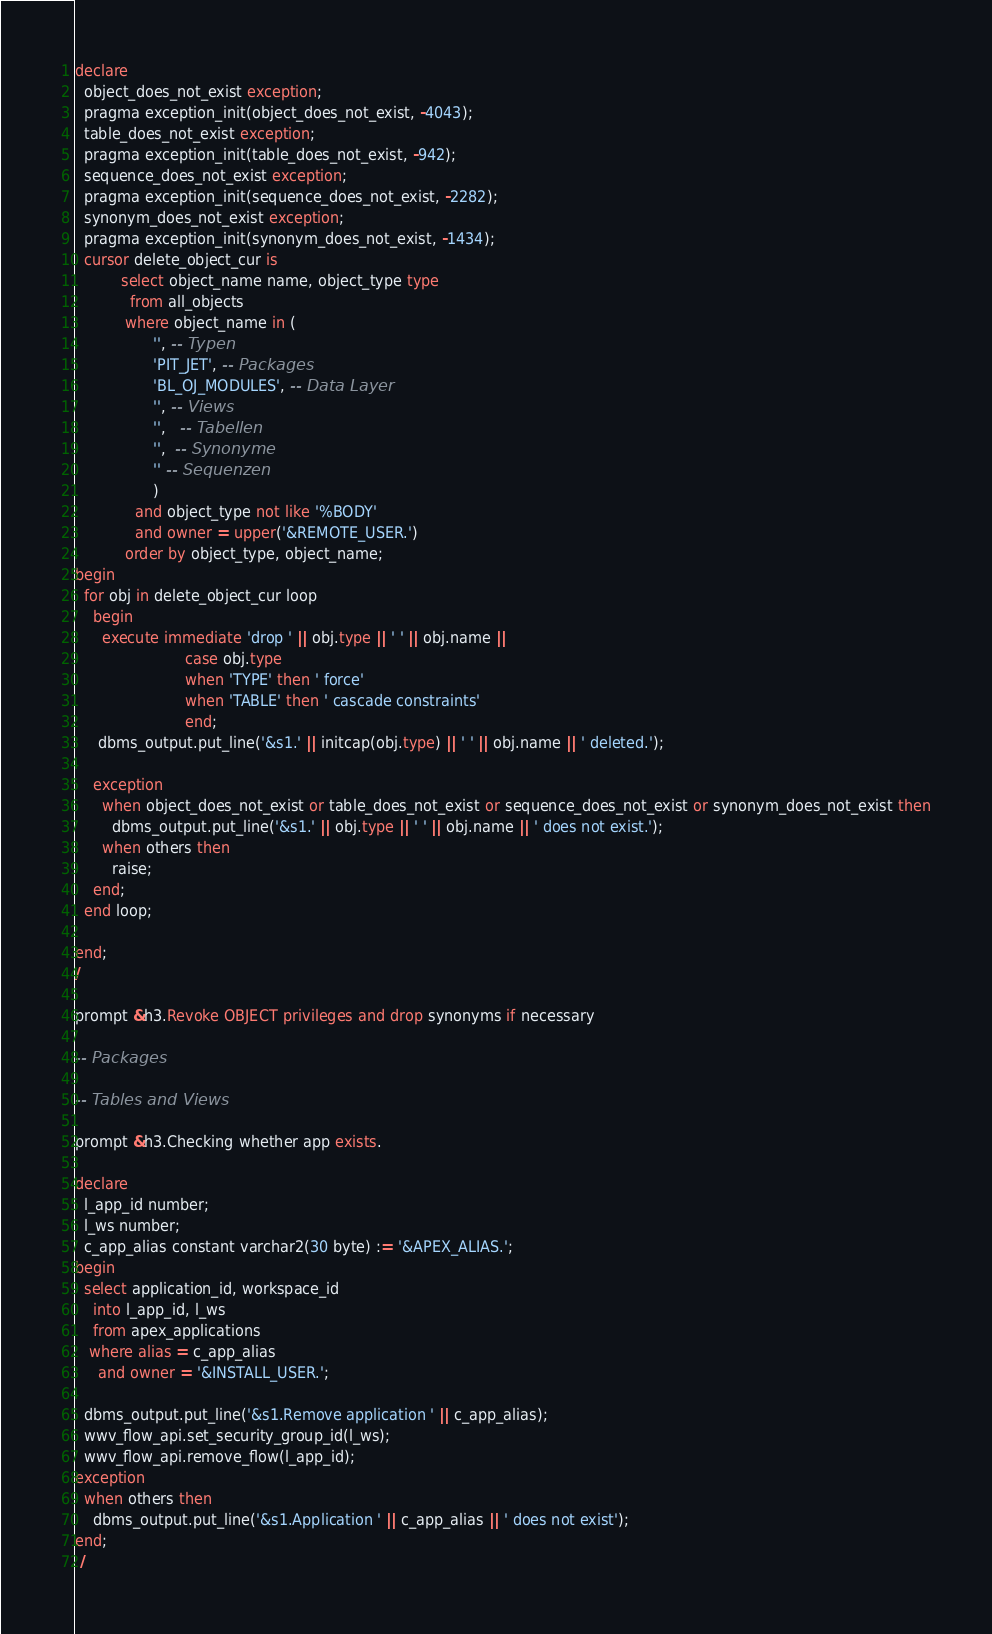<code> <loc_0><loc_0><loc_500><loc_500><_SQL_>declare
  object_does_not_exist exception;
  pragma exception_init(object_does_not_exist, -4043);
  table_does_not_exist exception;
  pragma exception_init(table_does_not_exist, -942);
  sequence_does_not_exist exception;
  pragma exception_init(sequence_does_not_exist, -2282);
  synonym_does_not_exist exception;
  pragma exception_init(synonym_does_not_exist, -1434);
  cursor delete_object_cur is
          select object_name name, object_type type
            from all_objects
           where object_name in (
                 '', -- Typen
                 'PIT_JET', -- Packages
                 'BL_OJ_MODULES', -- Data Layer
                 '', -- Views
                 '',   -- Tabellen
                 '',  -- Synonyme
                 '' -- Sequenzen
                 )
             and object_type not like '%BODY'
             and owner = upper('&REMOTE_USER.')
           order by object_type, object_name;
begin
  for obj in delete_object_cur loop
    begin
      execute immediate 'drop ' || obj.type || ' ' || obj.name ||
                        case obj.type 
                        when 'TYPE' then ' force' 
                        when 'TABLE' then ' cascade constraints' 
                        end;
     dbms_output.put_line('&s1.' || initcap(obj.type) || ' ' || obj.name || ' deleted.');
    
    exception
      when object_does_not_exist or table_does_not_exist or sequence_does_not_exist or synonym_does_not_exist then
        dbms_output.put_line('&s1.' || obj.type || ' ' || obj.name || ' does not exist.');
      when others then
        raise;
    end;
  end loop;
  
end;
/

prompt &h3.Revoke OBJECT privileges and drop synonyms if necessary

-- Packages

-- Tables and Views

prompt &h3.Checking whether app exists.

declare
  l_app_id number;
  l_ws number;
  c_app_alias constant varchar2(30 byte) := '&APEX_ALIAS.';  
begin
  select application_id, workspace_id
    into l_app_id, l_ws
    from apex_applications
   where alias = c_app_alias
     and owner = '&INSTALL_USER.';
   
  dbms_output.put_line('&s1.Remove application ' || c_app_alias);
  wwv_flow_api.set_security_group_id(l_ws);
  wwv_flow_api.remove_flow(l_app_id);
exception
  when others then
    dbms_output.put_line('&s1.Application ' || c_app_alias || ' does not exist');
end;
 /</code> 